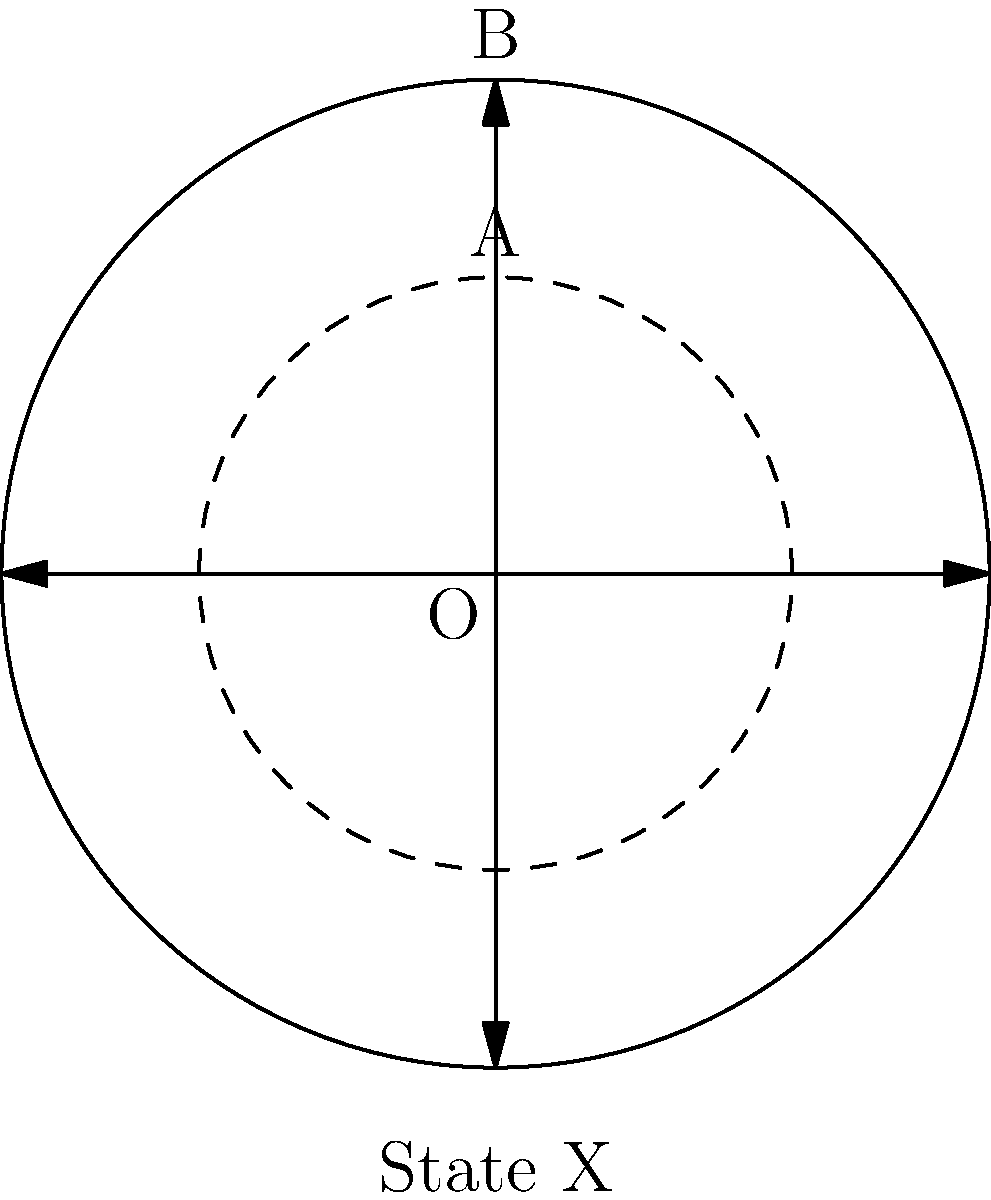In a circular representation of State X's population density, the inner circle A represents an urban core with a radius of 30 miles and a population density of 2000 people per square mile. The outer circle B, with a radius of 50 miles, represents the entire state. If the population density between circles A and B is 500 people per square mile, what is the total population of State X? Let's approach this step-by-step:

1) First, calculate the areas of both circles:
   Area of circle A: $A_A = \pi r_A^2 = \pi (30)^2 = 2827.43$ sq miles
   Area of circle B: $A_B = \pi r_B^2 = \pi (50)^2 = 7853.98$ sq miles

2) Calculate the area of the region between circles A and B:
   $A_{B-A} = A_B - A_A = 7853.98 - 2827.43 = 5026.55$ sq miles

3) Calculate the population in circle A:
   $P_A = 2000 \times 2827.43 = 5,654,860$ people

4) Calculate the population in the region between circles A and B:
   $P_{B-A} = 500 \times 5026.55 = 2,513,275$ people

5) Sum up the total population:
   $P_{total} = P_A + P_{B-A} = 5,654,860 + 2,513,275 = 8,168,135$ people

Therefore, the total population of State X is 8,168,135 people.
Answer: 8,168,135 people 